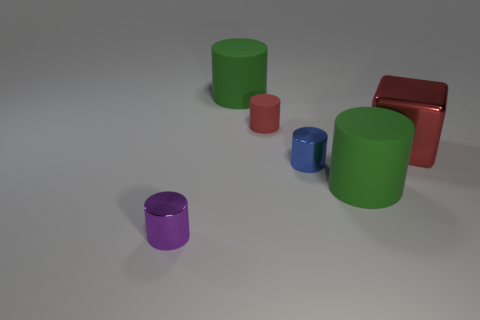The small rubber thing that is the same color as the cube is what shape?
Ensure brevity in your answer.  Cylinder. What number of other things have the same shape as the blue object?
Offer a very short reply. 4. What shape is the tiny purple thing that is made of the same material as the blue object?
Make the answer very short. Cylinder. The cylinder on the left side of the large thing left of the large cylinder that is in front of the tiny blue object is made of what material?
Your answer should be very brief. Metal. Do the blue thing and the metal cylinder on the left side of the red rubber cylinder have the same size?
Your answer should be very brief. Yes. What material is the small red thing that is the same shape as the tiny purple thing?
Keep it short and to the point. Rubber. There is a green rubber object that is behind the large green matte object that is on the right side of the small cylinder behind the blue cylinder; how big is it?
Ensure brevity in your answer.  Large. Do the red matte cylinder and the red metal object have the same size?
Your answer should be very brief. No. What material is the green object that is behind the big matte cylinder to the right of the tiny red rubber object made of?
Your answer should be compact. Rubber. There is a big green rubber thing that is to the right of the small matte cylinder; does it have the same shape as the large object behind the large red cube?
Provide a succinct answer. Yes. 